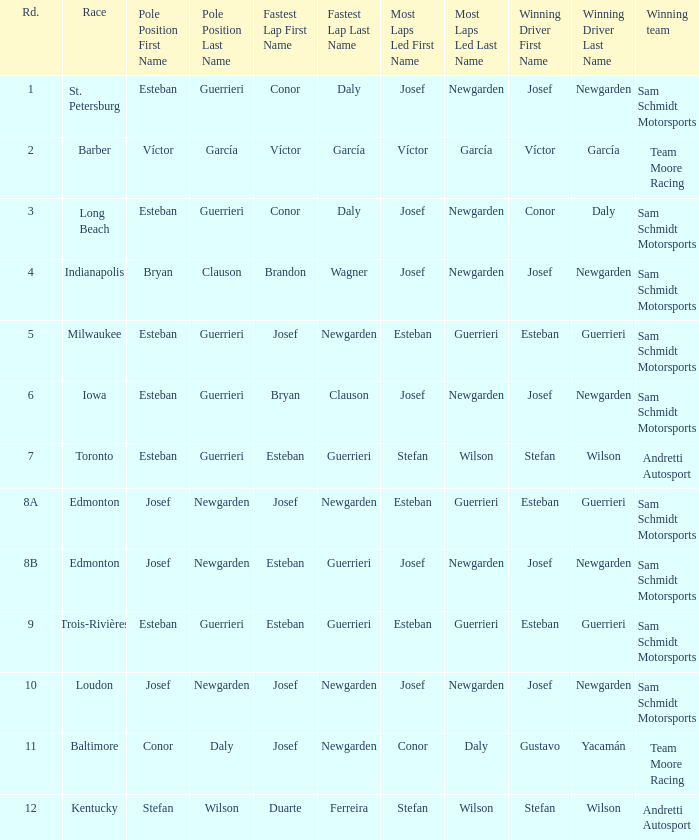Who had the fastest lap(s) when stefan wilson had the pole? Duarte Ferreira. 